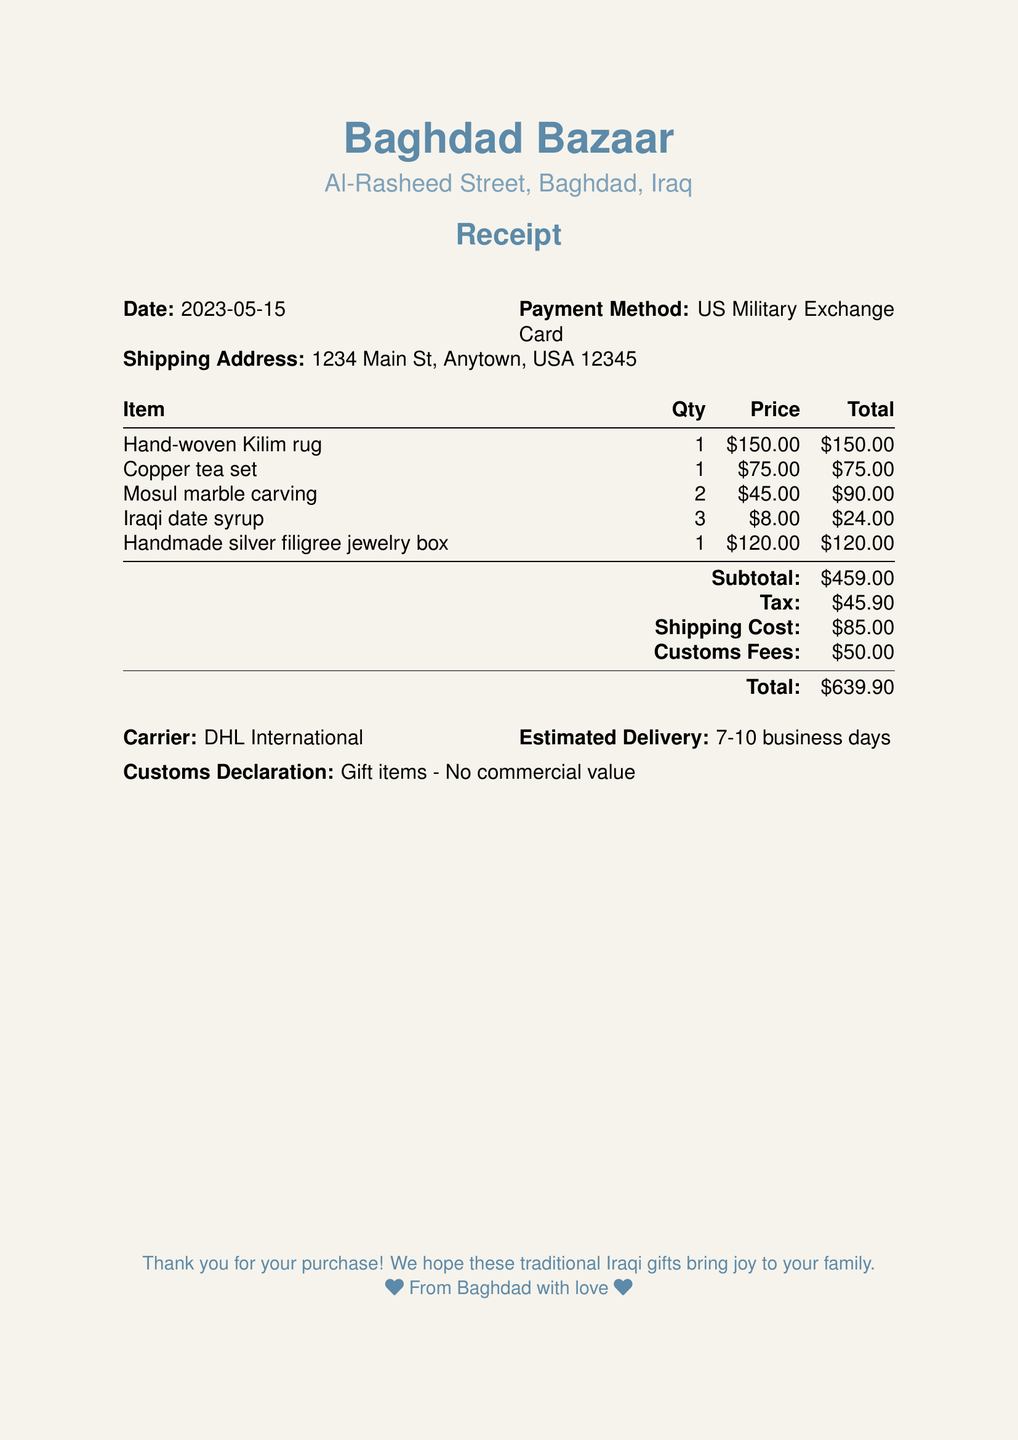What is the date of the receipt? The date of the receipt is specified in the document as the day it was issued.
Answer: 2023-05-15 How many items were purchased in total? The total number of items is derived from the quantities listed for each item in the receipt.
Answer: 8 What is the total cost including shipping and customs fees? The total cost is calculated from the subtotal, tax, shipping cost, and customs fees.
Answer: $639.90 What payment method was used? The document explicitly states the method of payment used for the purchase.
Answer: US Military Exchange Card What is the estimated delivery time? The estimated delivery is given in the document, outlining the timeframe for arrival of the package.
Answer: 7-10 business days What is the shipping cost? The shipping cost is specifically listed in the receipt and contributes to the overall total.
Answer: $85.00 What is the subtotal before tax and fees? The subtotal is the sum of all items purchased before tax, shipping, and customs fees are added.
Answer: $459.00 How many Mosul marble carvings were purchased? The number of Mosul marble carvings is stated in the itemized list of purchases.
Answer: 2 What carrier is used for shipping? The document indicates the shipping service that will deliver the items to the specified address.
Answer: DHL International 